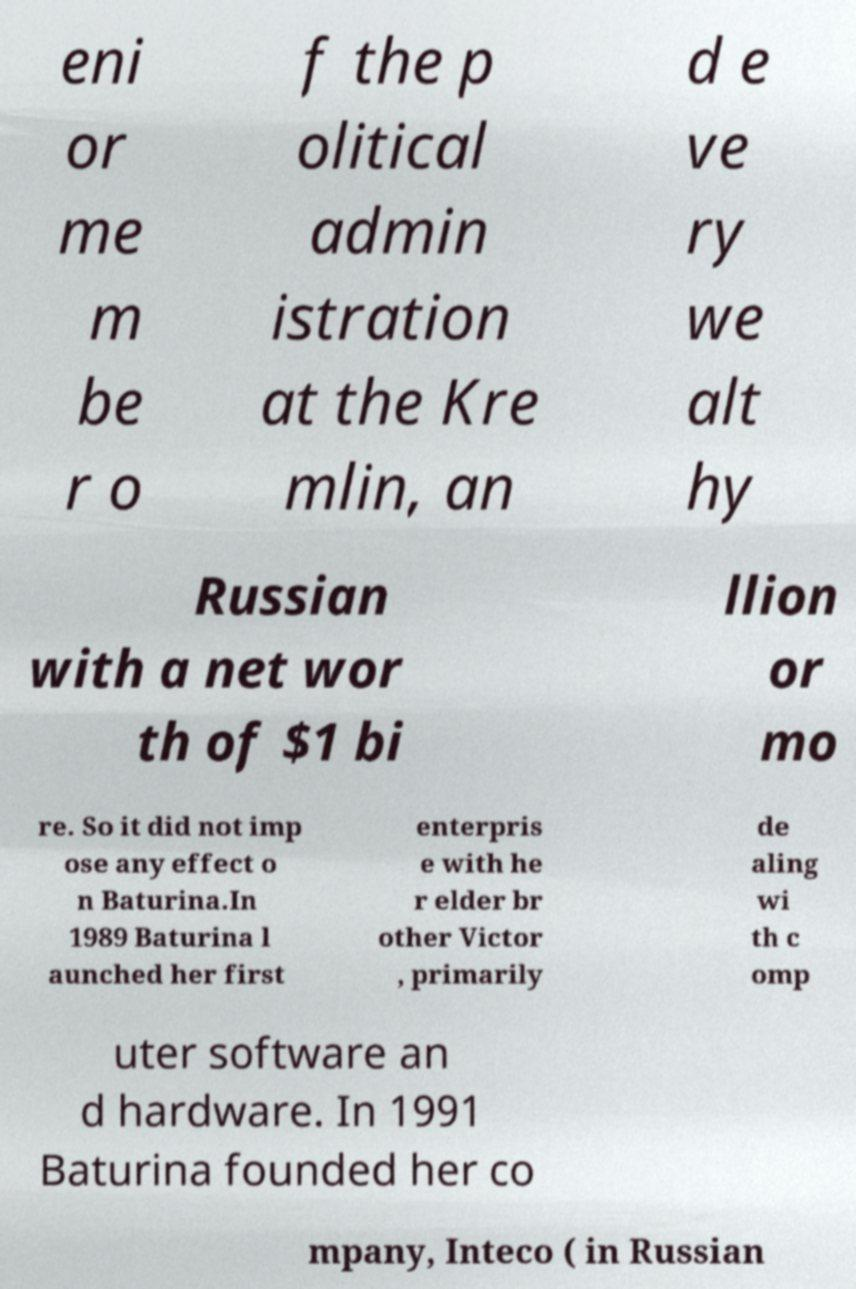What messages or text are displayed in this image? I need them in a readable, typed format. eni or me m be r o f the p olitical admin istration at the Kre mlin, an d e ve ry we alt hy Russian with a net wor th of $1 bi llion or mo re. So it did not imp ose any effect o n Baturina.In 1989 Baturina l aunched her first enterpris e with he r elder br other Victor , primarily de aling wi th c omp uter software an d hardware. In 1991 Baturina founded her co mpany, Inteco ( in Russian 